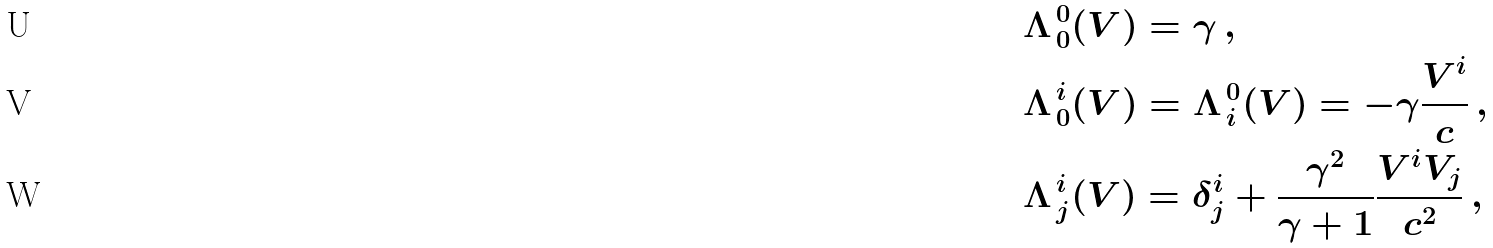<formula> <loc_0><loc_0><loc_500><loc_500>& \Lambda ^ { \, 0 } _ { \, 0 } ( V ) = \gamma \, , \\ & \Lambda ^ { \, i } _ { \, 0 } ( V ) = \Lambda ^ { \, 0 } _ { \, i } ( V ) = - \gamma \frac { V ^ { i } } { c } \, , \\ & \Lambda ^ { \, i } _ { \, j } ( V ) = \delta ^ { i } _ { j } + \frac { \gamma ^ { 2 } } { \gamma + 1 } \frac { V ^ { i } V _ { j } } { c ^ { 2 } } \, ,</formula> 